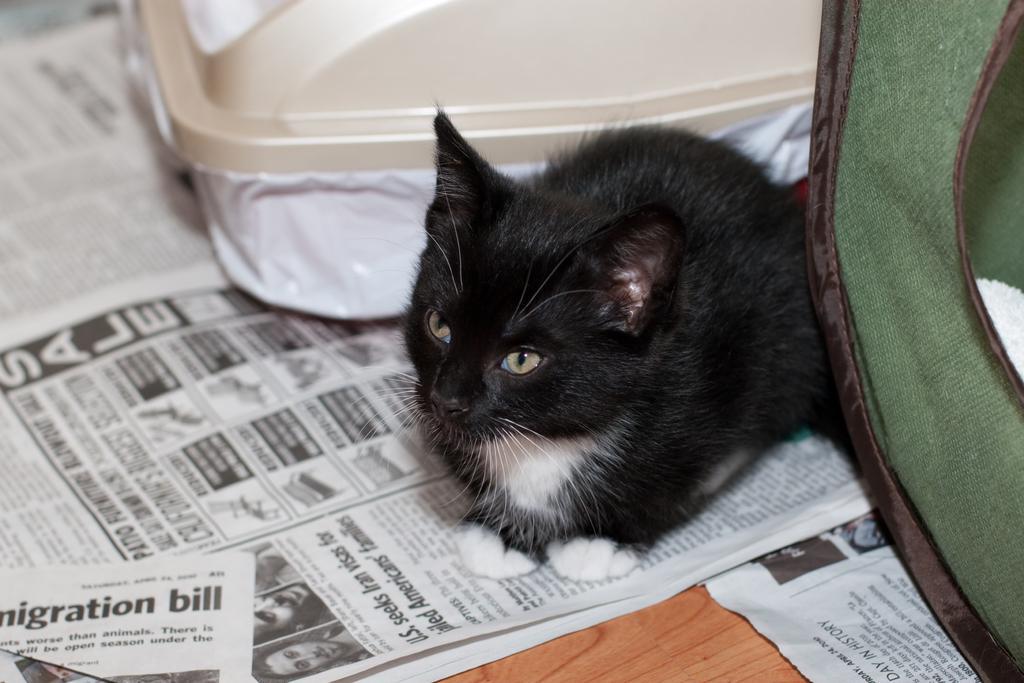Describe this image in one or two sentences. In the foreground of this image, there is a black cat sitting on a paper. On the right, there is a green object and at the top, there is a cream color object. At the bottom, there is the wooden surface. 